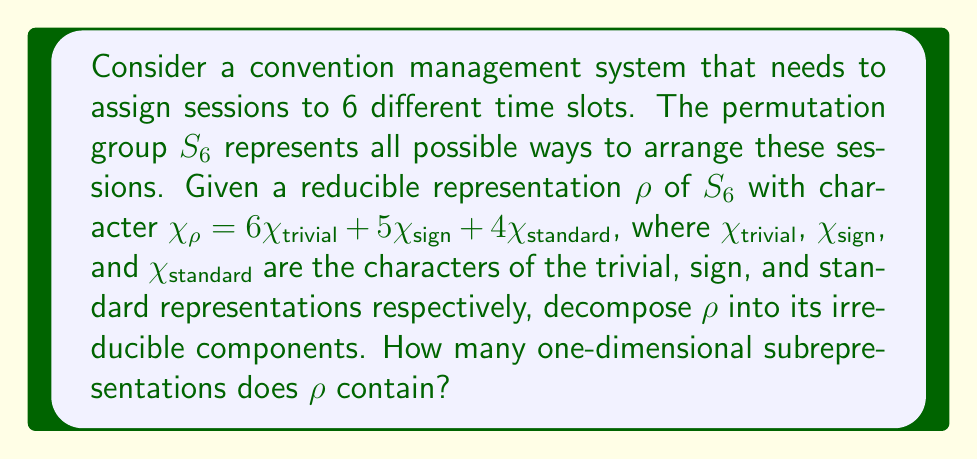Can you solve this math problem? To solve this problem, we'll follow these steps:

1) First, recall the irreducible representations of $S_6$:
   - The trivial representation (1-dimensional)
   - The sign representation (1-dimensional)
   - The standard representation (5-dimensional)

2) The given character $\chi_\rho$ is already expressed as a linear combination of these irreducible characters:

   $\chi_\rho = 6\chi_{trivial} + 5\chi_{sign} + 4\chi_{standard}$

3) This decomposition tells us that:
   - The trivial representation appears 6 times
   - The sign representation appears 5 times
   - The standard representation appears 4 times

4) To find the number of one-dimensional subrepresentations, we need to count the occurrences of one-dimensional irreducible representations in the decomposition.

5) The one-dimensional irreducible representations of $S_6$ are:
   - The trivial representation (occurs 6 times)
   - The sign representation (occurs 5 times)

6) Therefore, the total number of one-dimensional subrepresentations is:

   $6 + 5 = 11$

This decomposition allows for optimal session assignments by grouping similar sessions together based on the irreducible components, which can lead to more efficient scheduling in the convention management system.
Answer: 11 